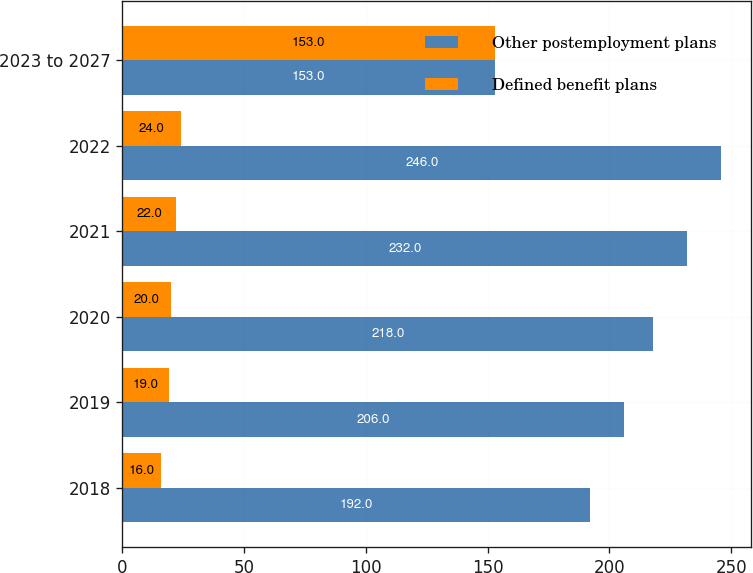<chart> <loc_0><loc_0><loc_500><loc_500><stacked_bar_chart><ecel><fcel>2018<fcel>2019<fcel>2020<fcel>2021<fcel>2022<fcel>2023 to 2027<nl><fcel>Other postemployment plans<fcel>192<fcel>206<fcel>218<fcel>232<fcel>246<fcel>153<nl><fcel>Defined benefit plans<fcel>16<fcel>19<fcel>20<fcel>22<fcel>24<fcel>153<nl></chart> 